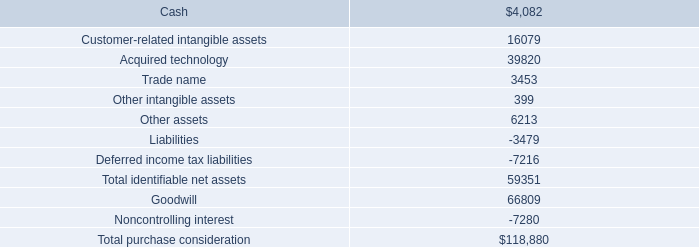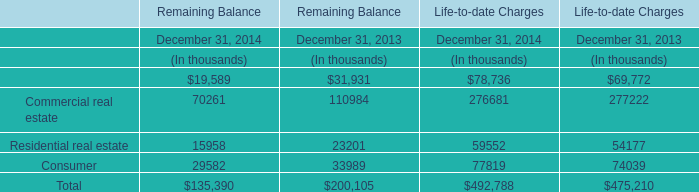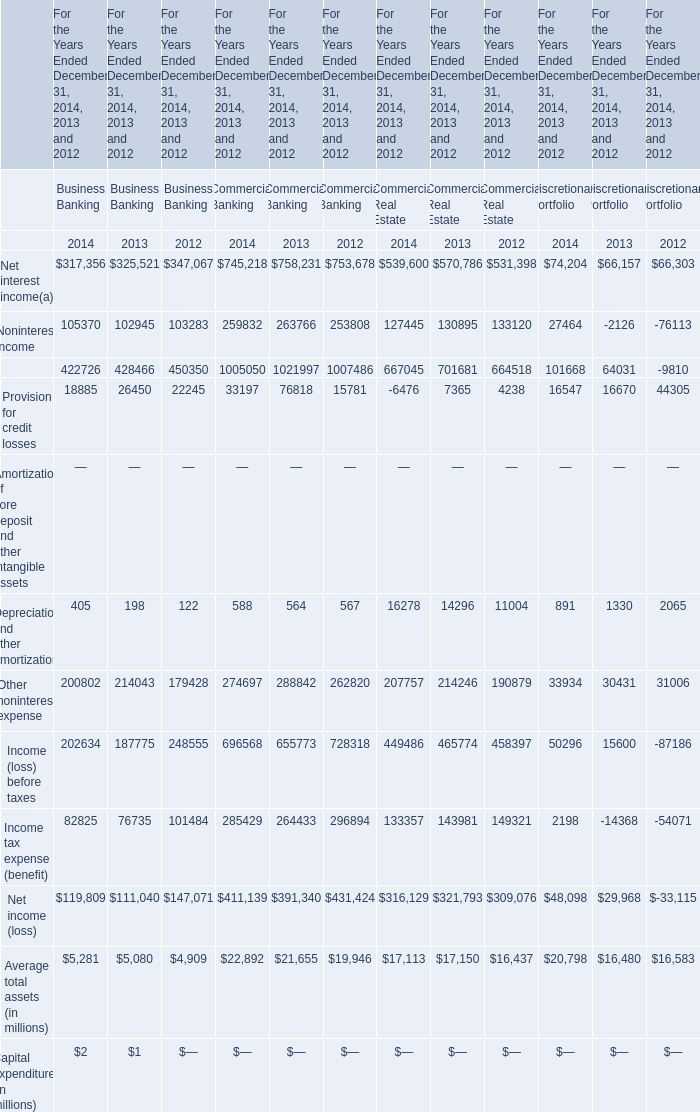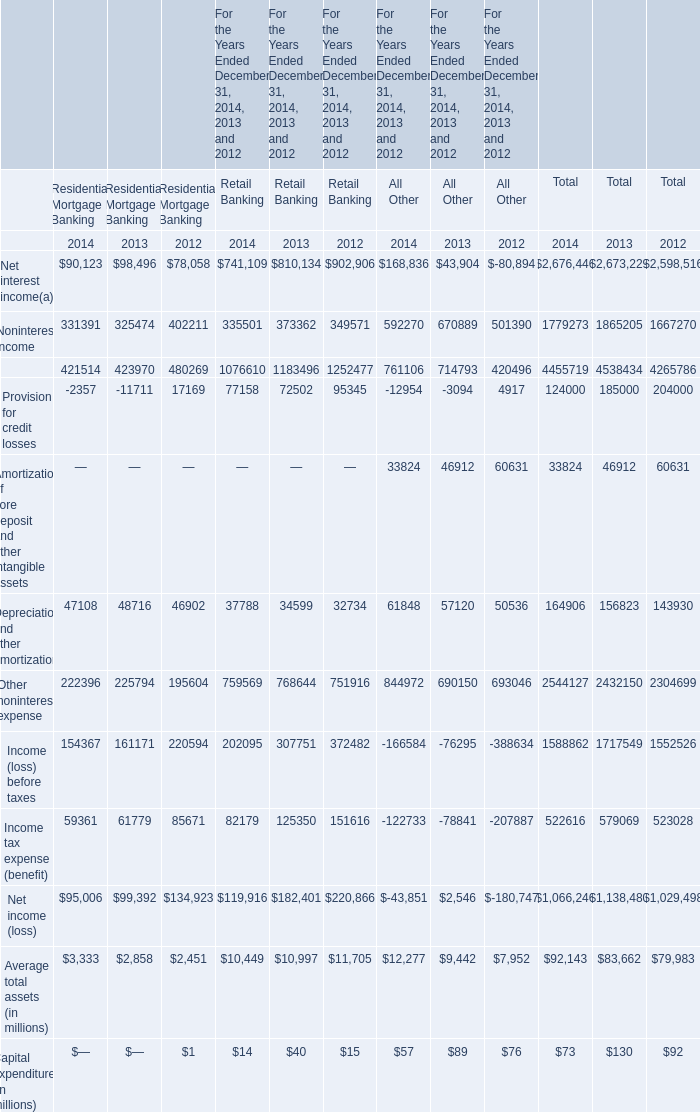In the year with highest Depreciation and other amortization for Commercial Banking, what's the growing rate of Other noninterest expense for Commercial Banking? 
Computations: ((274697 - 288842) / 288842)
Answer: -0.04897. 